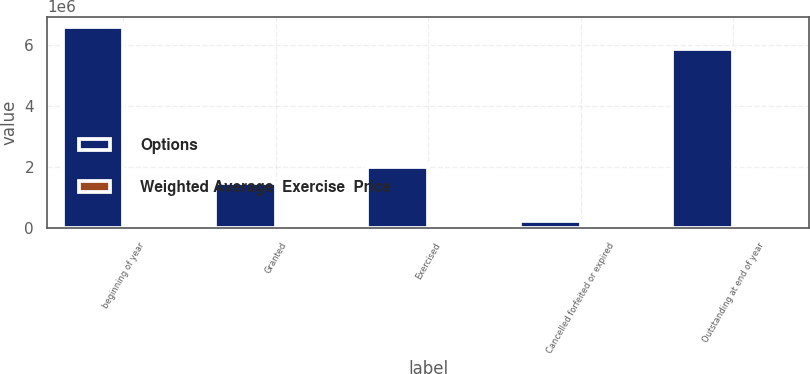<chart> <loc_0><loc_0><loc_500><loc_500><stacked_bar_chart><ecel><fcel>beginning of year<fcel>Granted<fcel>Exercised<fcel>Cancelled forfeited or expired<fcel>Outstanding at end of year<nl><fcel>Options<fcel>6.6168e+06<fcel>1.4813e+06<fcel>2.0018e+06<fcel>229400<fcel>5.8669e+06<nl><fcel>Weighted Average  Exercise  Price<fcel>48<fcel>61<fcel>45<fcel>56<fcel>52<nl></chart> 